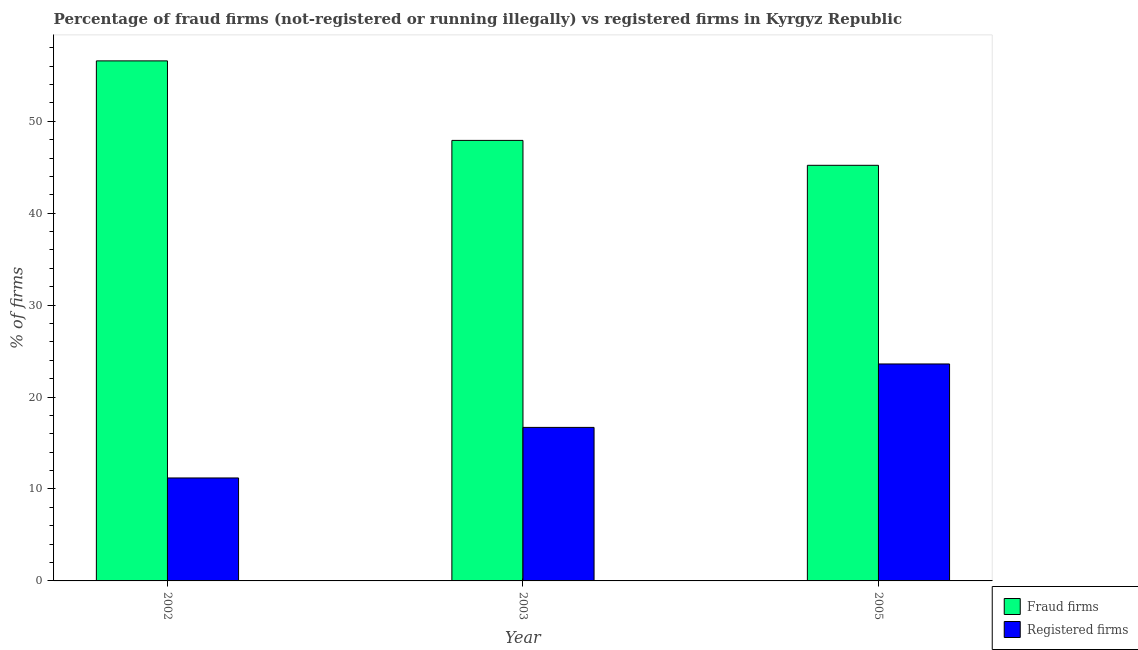How many different coloured bars are there?
Keep it short and to the point. 2. How many groups of bars are there?
Make the answer very short. 3. Are the number of bars on each tick of the X-axis equal?
Ensure brevity in your answer.  Yes. How many bars are there on the 1st tick from the left?
Provide a succinct answer. 2. What is the label of the 2nd group of bars from the left?
Ensure brevity in your answer.  2003. What is the percentage of registered firms in 2002?
Provide a succinct answer. 11.2. Across all years, what is the maximum percentage of registered firms?
Your answer should be compact. 23.6. Across all years, what is the minimum percentage of fraud firms?
Your answer should be very brief. 45.21. In which year was the percentage of registered firms maximum?
Ensure brevity in your answer.  2005. In which year was the percentage of fraud firms minimum?
Ensure brevity in your answer.  2005. What is the total percentage of registered firms in the graph?
Offer a terse response. 51.5. What is the difference between the percentage of registered firms in 2002 and that in 2005?
Give a very brief answer. -12.4. What is the difference between the percentage of registered firms in 2005 and the percentage of fraud firms in 2002?
Provide a succinct answer. 12.4. What is the average percentage of fraud firms per year?
Your answer should be compact. 49.9. In the year 2002, what is the difference between the percentage of registered firms and percentage of fraud firms?
Ensure brevity in your answer.  0. What is the ratio of the percentage of fraud firms in 2002 to that in 2005?
Give a very brief answer. 1.25. Is the percentage of registered firms in 2002 less than that in 2003?
Offer a terse response. Yes. Is the difference between the percentage of fraud firms in 2003 and 2005 greater than the difference between the percentage of registered firms in 2003 and 2005?
Your response must be concise. No. What is the difference between the highest and the second highest percentage of registered firms?
Provide a short and direct response. 6.9. What is the difference between the highest and the lowest percentage of registered firms?
Your answer should be very brief. 12.4. In how many years, is the percentage of fraud firms greater than the average percentage of fraud firms taken over all years?
Your answer should be compact. 1. What does the 2nd bar from the left in 2003 represents?
Your answer should be compact. Registered firms. What does the 2nd bar from the right in 2002 represents?
Keep it short and to the point. Fraud firms. Are all the bars in the graph horizontal?
Ensure brevity in your answer.  No. How many years are there in the graph?
Offer a terse response. 3. What is the difference between two consecutive major ticks on the Y-axis?
Keep it short and to the point. 10. Does the graph contain any zero values?
Your answer should be compact. No. Does the graph contain grids?
Ensure brevity in your answer.  No. What is the title of the graph?
Give a very brief answer. Percentage of fraud firms (not-registered or running illegally) vs registered firms in Kyrgyz Republic. What is the label or title of the Y-axis?
Give a very brief answer. % of firms. What is the % of firms in Fraud firms in 2002?
Offer a very short reply. 56.57. What is the % of firms in Fraud firms in 2003?
Keep it short and to the point. 47.92. What is the % of firms in Fraud firms in 2005?
Your answer should be compact. 45.21. What is the % of firms of Registered firms in 2005?
Give a very brief answer. 23.6. Across all years, what is the maximum % of firms of Fraud firms?
Your answer should be compact. 56.57. Across all years, what is the maximum % of firms of Registered firms?
Give a very brief answer. 23.6. Across all years, what is the minimum % of firms of Fraud firms?
Your answer should be very brief. 45.21. What is the total % of firms in Fraud firms in the graph?
Ensure brevity in your answer.  149.7. What is the total % of firms of Registered firms in the graph?
Make the answer very short. 51.5. What is the difference between the % of firms in Fraud firms in 2002 and that in 2003?
Provide a succinct answer. 8.65. What is the difference between the % of firms of Fraud firms in 2002 and that in 2005?
Keep it short and to the point. 11.36. What is the difference between the % of firms of Fraud firms in 2003 and that in 2005?
Provide a short and direct response. 2.71. What is the difference between the % of firms of Fraud firms in 2002 and the % of firms of Registered firms in 2003?
Provide a succinct answer. 39.87. What is the difference between the % of firms of Fraud firms in 2002 and the % of firms of Registered firms in 2005?
Give a very brief answer. 32.97. What is the difference between the % of firms in Fraud firms in 2003 and the % of firms in Registered firms in 2005?
Your response must be concise. 24.32. What is the average % of firms in Fraud firms per year?
Offer a very short reply. 49.9. What is the average % of firms in Registered firms per year?
Keep it short and to the point. 17.17. In the year 2002, what is the difference between the % of firms of Fraud firms and % of firms of Registered firms?
Provide a succinct answer. 45.37. In the year 2003, what is the difference between the % of firms in Fraud firms and % of firms in Registered firms?
Your answer should be very brief. 31.22. In the year 2005, what is the difference between the % of firms of Fraud firms and % of firms of Registered firms?
Make the answer very short. 21.61. What is the ratio of the % of firms of Fraud firms in 2002 to that in 2003?
Offer a very short reply. 1.18. What is the ratio of the % of firms of Registered firms in 2002 to that in 2003?
Keep it short and to the point. 0.67. What is the ratio of the % of firms in Fraud firms in 2002 to that in 2005?
Keep it short and to the point. 1.25. What is the ratio of the % of firms in Registered firms in 2002 to that in 2005?
Ensure brevity in your answer.  0.47. What is the ratio of the % of firms in Fraud firms in 2003 to that in 2005?
Keep it short and to the point. 1.06. What is the ratio of the % of firms in Registered firms in 2003 to that in 2005?
Offer a terse response. 0.71. What is the difference between the highest and the second highest % of firms of Fraud firms?
Your answer should be very brief. 8.65. What is the difference between the highest and the second highest % of firms in Registered firms?
Your answer should be very brief. 6.9. What is the difference between the highest and the lowest % of firms in Fraud firms?
Provide a short and direct response. 11.36. 